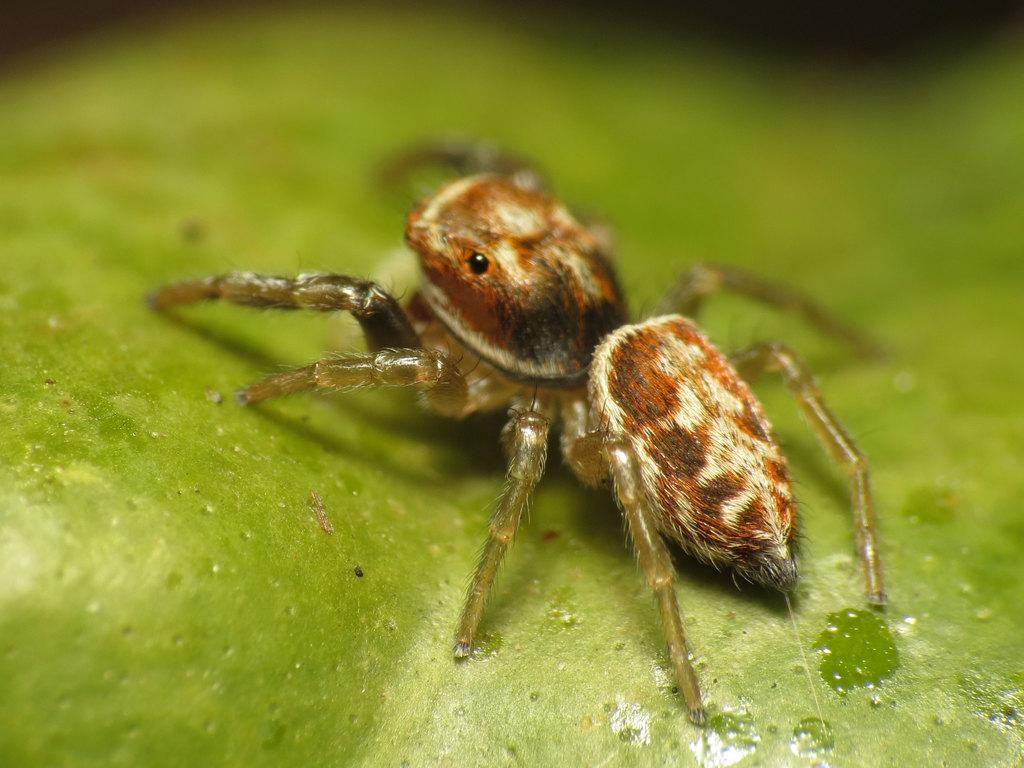What is the color of the surface in the image? The surface in the image is green. What can be seen on the green surface? There is a spider on the green surface. What type of cheese is being used to fill the hole in the image? There is no hole or cheese present in the image; it features a green surface with a spider on it. 